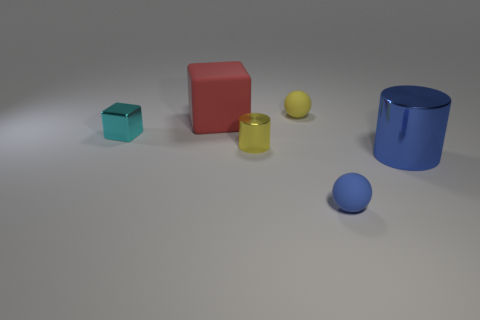Add 4 matte cubes. How many objects exist? 10 Subtract all blue spheres. Subtract all red blocks. How many spheres are left? 1 Subtract all cylinders. How many objects are left? 4 Subtract all big red objects. Subtract all large metal cylinders. How many objects are left? 4 Add 1 small blue matte objects. How many small blue matte objects are left? 2 Add 4 red balls. How many red balls exist? 4 Subtract 1 blue cylinders. How many objects are left? 5 